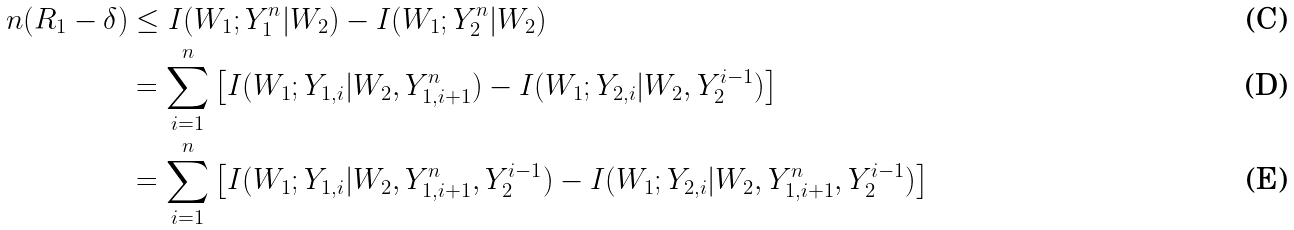<formula> <loc_0><loc_0><loc_500><loc_500>n ( R _ { 1 } - \delta ) & \leq I ( W _ { 1 } ; Y _ { 1 } ^ { n } | W _ { 2 } ) - I ( W _ { 1 } ; Y _ { 2 } ^ { n } | W _ { 2 } ) \\ & = \sum _ { i = 1 } ^ { n } \left [ I ( W _ { 1 } ; Y _ { 1 , i } | W _ { 2 } , Y _ { 1 , i + 1 } ^ { n } ) - I ( W _ { 1 } ; Y _ { 2 , i } | W _ { 2 } , Y _ { 2 } ^ { i - 1 } ) \right ] \\ & = \sum _ { i = 1 } ^ { n } \left [ I ( W _ { 1 } ; Y _ { 1 , i } | W _ { 2 } , Y _ { 1 , i + 1 } ^ { n } , Y _ { 2 } ^ { i - 1 } ) - I ( W _ { 1 } ; Y _ { 2 , i } | W _ { 2 } , Y _ { 1 , i + 1 } ^ { n } , Y _ { 2 } ^ { i - 1 } ) \right ]</formula> 